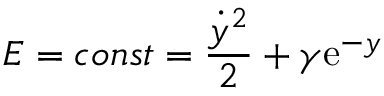<formula> <loc_0><loc_0><loc_500><loc_500>E = c o n s t = { \frac { \dot { y } ^ { 2 } } { 2 } } + \gamma e ^ { - y }</formula> 